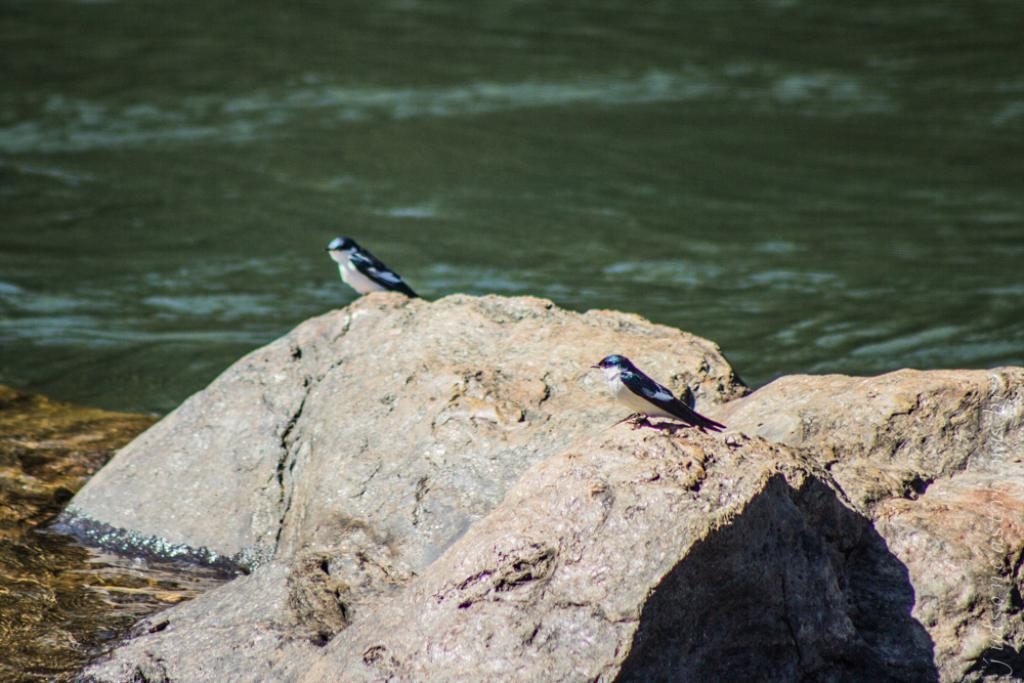How many birds can be seen in the image? There are two birds in the image. Where are the birds located? The birds are on the rocks. What can be seen in the background of the image? There is water visible in the background of the image. What type of thunder can be heard in the image? There is no thunder present in the image, as it is a visual representation and does not include sound. 